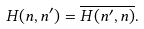<formula> <loc_0><loc_0><loc_500><loc_500>H ( n , n ^ { \prime } ) = \overline { H ( n ^ { \prime } , n ) } .</formula> 